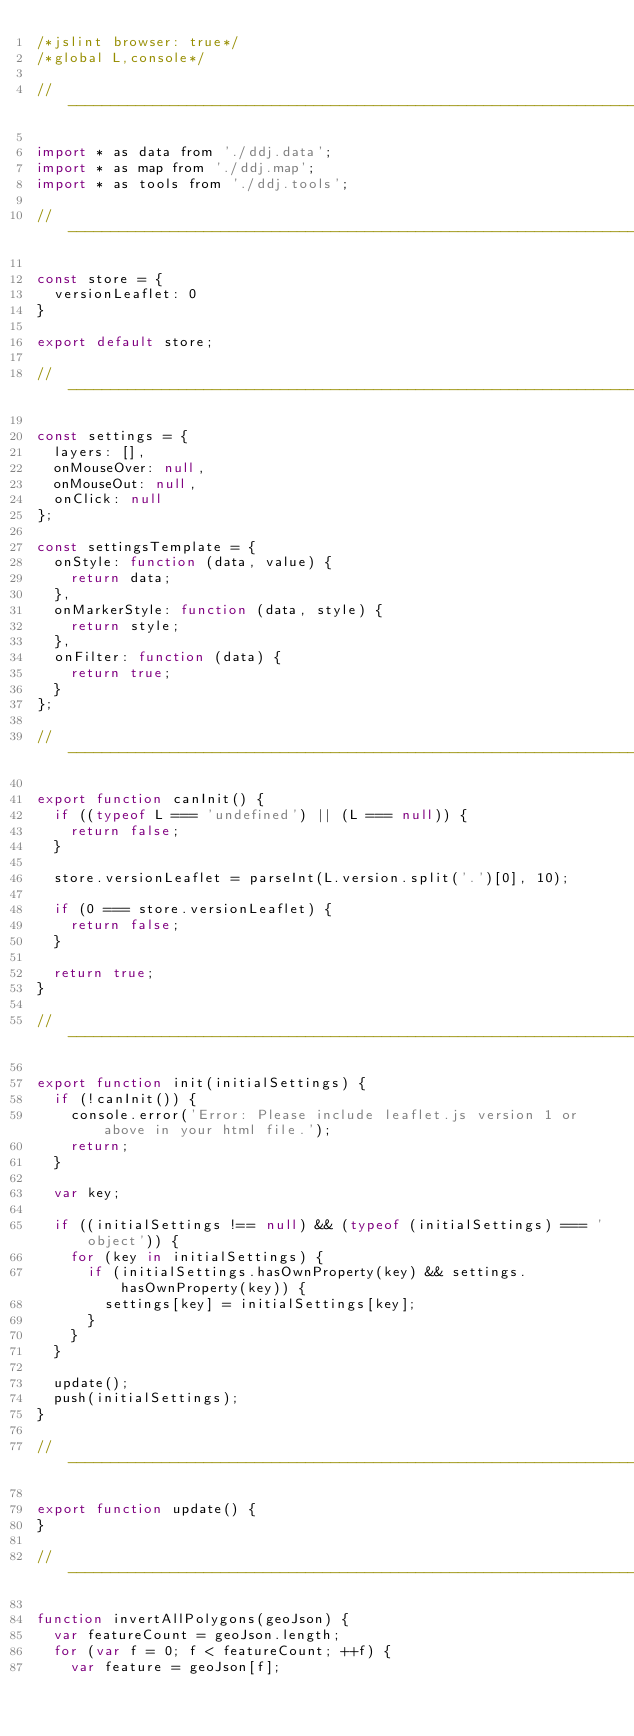Convert code to text. <code><loc_0><loc_0><loc_500><loc_500><_JavaScript_>/*jslint browser: true*/
/*global L,console*/

// -----------------------------------------------------------------------------

import * as data from './ddj.data';
import * as map from './ddj.map';
import * as tools from './ddj.tools';

// -----------------------------------------------------------------------------

const store = {
	versionLeaflet: 0
}

export default store;

// -----------------------------------------------------------------------------

const settings = {
	layers: [],
	onMouseOver: null,
	onMouseOut: null,
	onClick: null
};

const settingsTemplate = {
	onStyle: function (data, value) {
		return data;
	},
	onMarkerStyle: function (data, style) {
		return style;
	},
	onFilter: function (data) {
		return true;
	}
};

// -----------------------------------------------------------------------------

export function canInit() {
	if ((typeof L === 'undefined') || (L === null)) {
		return false;
	}

	store.versionLeaflet = parseInt(L.version.split('.')[0], 10);

	if (0 === store.versionLeaflet) {
		return false;
	}

	return true;
}

// -----------------------------------------------------------------------------

export function init(initialSettings) {
	if (!canInit()) {
		console.error('Error: Please include leaflet.js version 1 or above in your html file.');
		return;
	}

	var key;

	if ((initialSettings !== null) && (typeof (initialSettings) === 'object')) {
		for (key in initialSettings) {
			if (initialSettings.hasOwnProperty(key) && settings.hasOwnProperty(key)) {
				settings[key] = initialSettings[key];
			}
		}
	}

	update();
	push(initialSettings);
}

// -----------------------------------------------------------------------------

export function update() {
}

// -----------------------------------------------------------------------------

function invertAllPolygons(geoJson) {
	var featureCount = geoJson.length;
	for (var f = 0; f < featureCount; ++f) {
		var feature = geoJson[f];</code> 